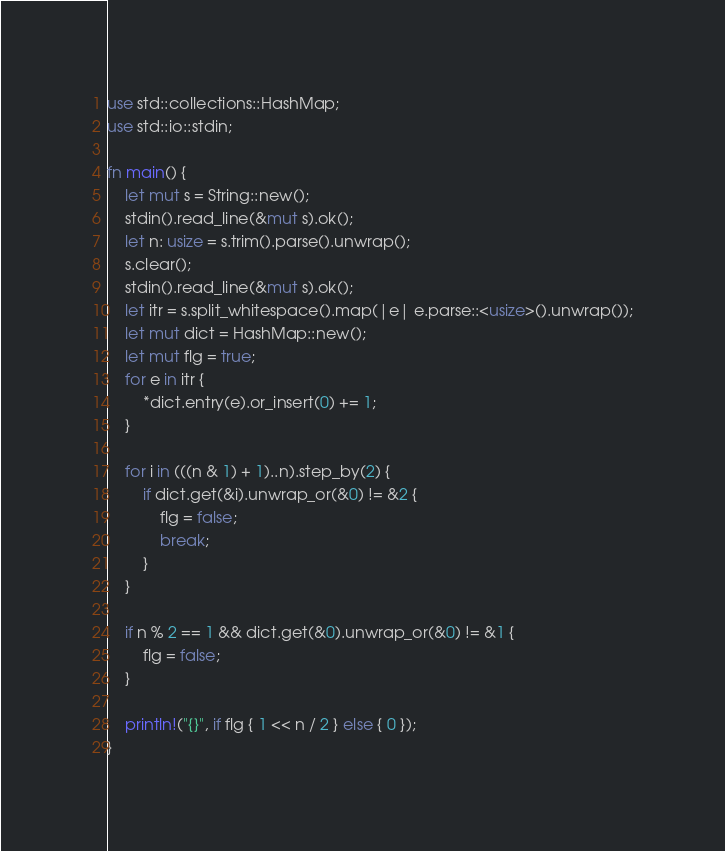Convert code to text. <code><loc_0><loc_0><loc_500><loc_500><_Rust_>use std::collections::HashMap;
use std::io::stdin;

fn main() {
    let mut s = String::new();
    stdin().read_line(&mut s).ok();
    let n: usize = s.trim().parse().unwrap();
    s.clear();
    stdin().read_line(&mut s).ok();
    let itr = s.split_whitespace().map(|e| e.parse::<usize>().unwrap());
    let mut dict = HashMap::new();
    let mut flg = true;
    for e in itr {
        *dict.entry(e).or_insert(0) += 1;
    }

    for i in (((n & 1) + 1)..n).step_by(2) {
        if dict.get(&i).unwrap_or(&0) != &2 {
            flg = false;
            break;
        }
    }

    if n % 2 == 1 && dict.get(&0).unwrap_or(&0) != &1 {
        flg = false;
    }

    println!("{}", if flg { 1 << n / 2 } else { 0 });
}
</code> 